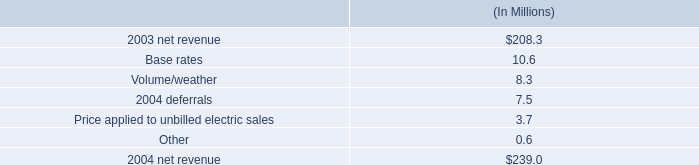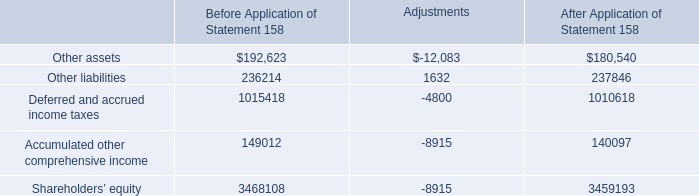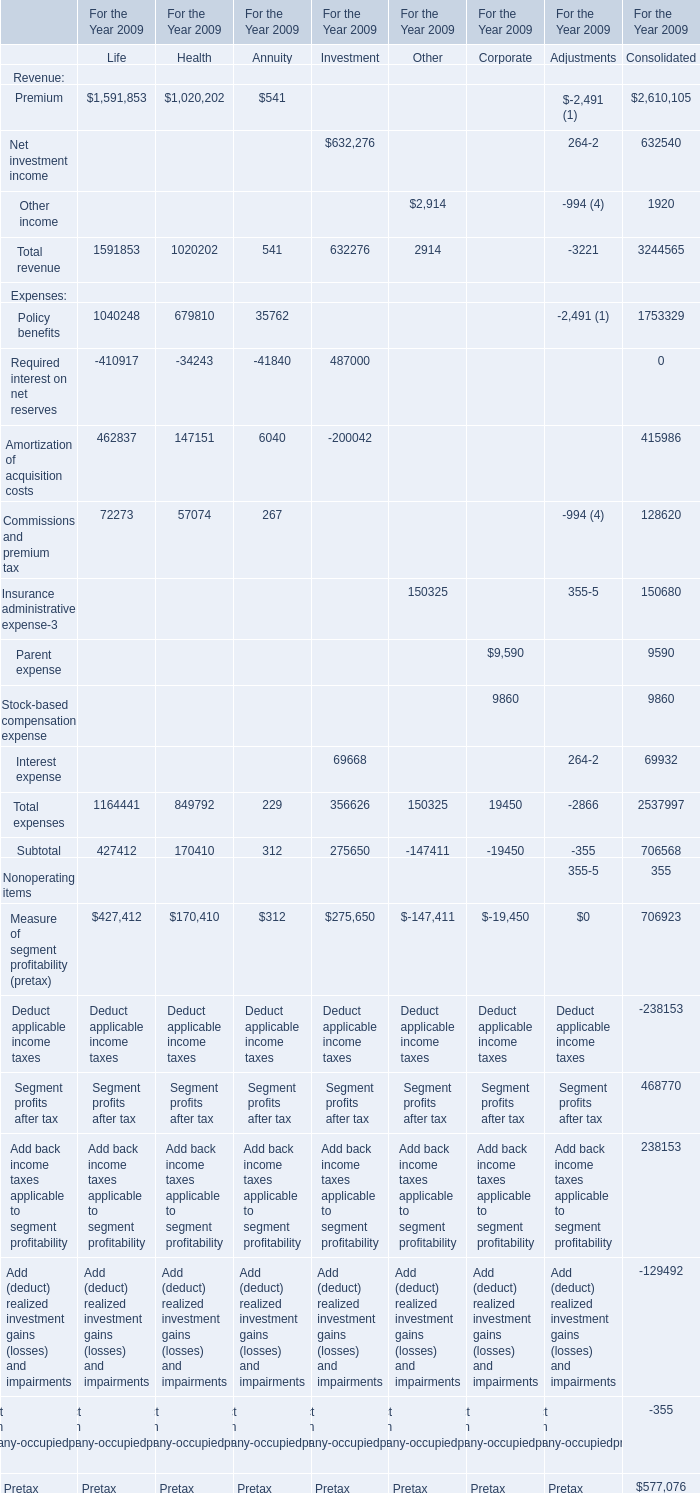What's the sum of Other liabilities of Before Application of Statement 158, Other income of For the Year 2009 Other, and Premium of For the Year 2009 Life ? 
Computations: ((236214.0 + 2914.0) + 1591853.0)
Answer: 1830981.0. 